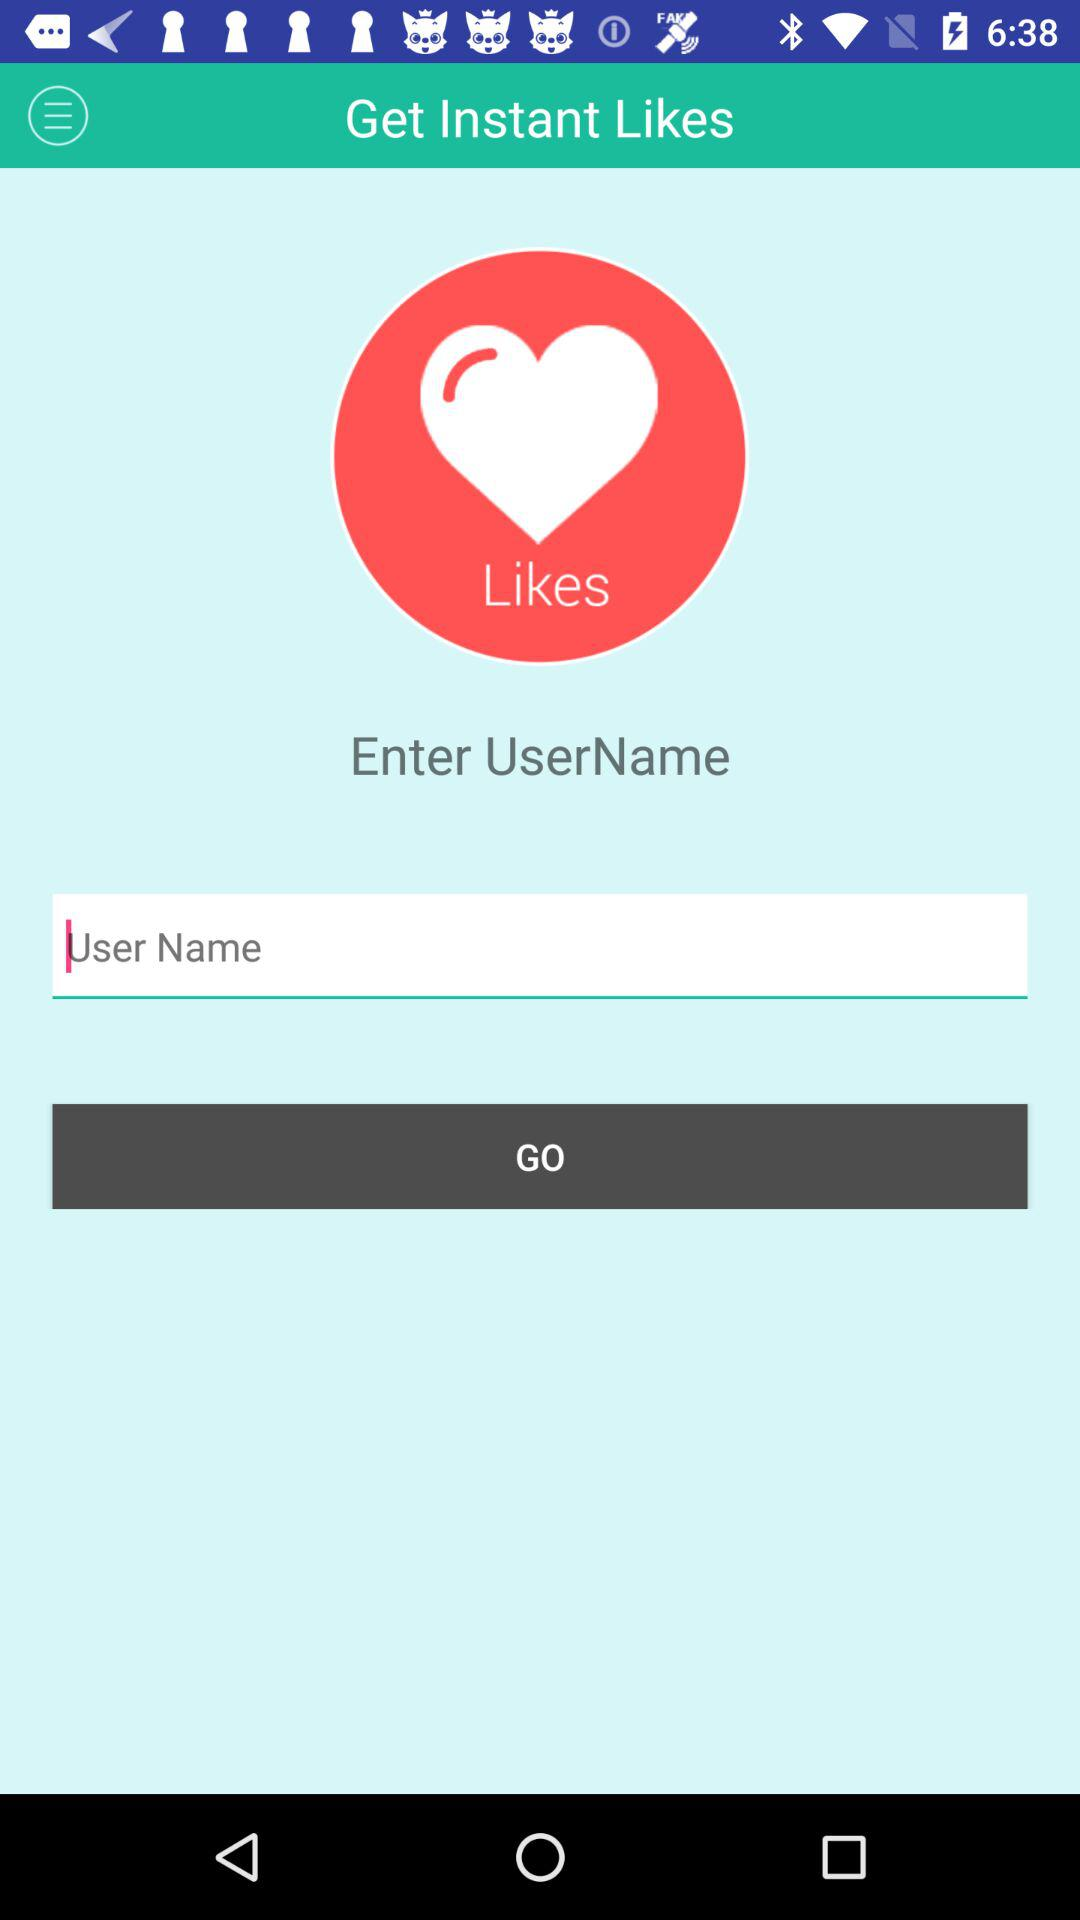What is the application name? The application name is "Get Instant Likes". 